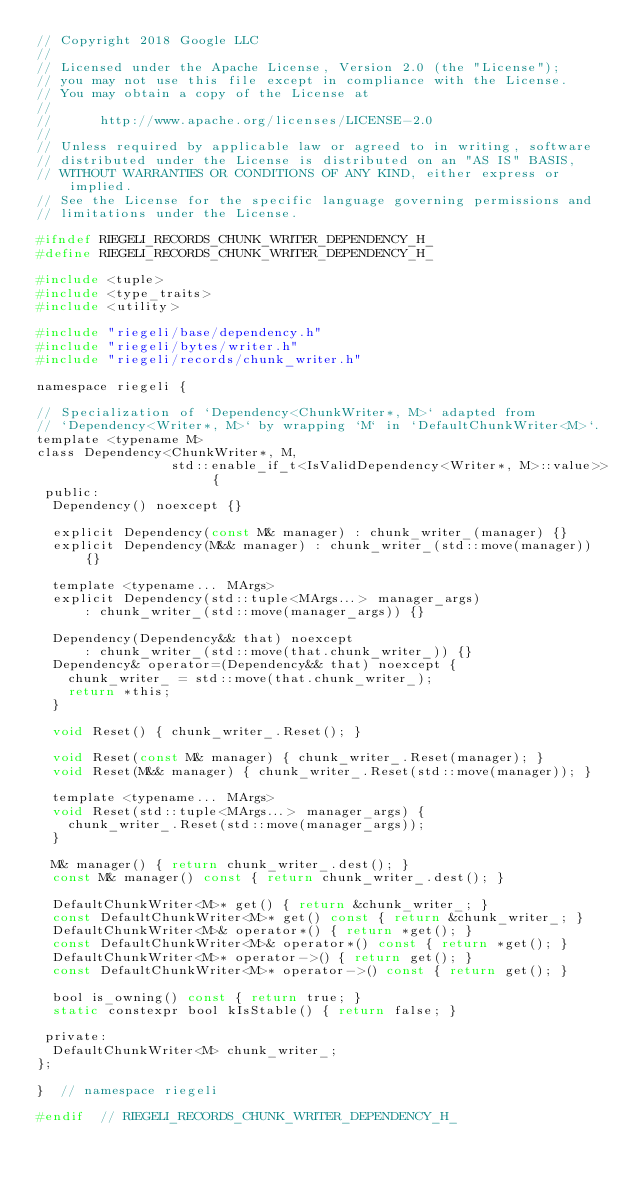<code> <loc_0><loc_0><loc_500><loc_500><_C_>// Copyright 2018 Google LLC
//
// Licensed under the Apache License, Version 2.0 (the "License");
// you may not use this file except in compliance with the License.
// You may obtain a copy of the License at
//
//      http://www.apache.org/licenses/LICENSE-2.0
//
// Unless required by applicable law or agreed to in writing, software
// distributed under the License is distributed on an "AS IS" BASIS,
// WITHOUT WARRANTIES OR CONDITIONS OF ANY KIND, either express or implied.
// See the License for the specific language governing permissions and
// limitations under the License.

#ifndef RIEGELI_RECORDS_CHUNK_WRITER_DEPENDENCY_H_
#define RIEGELI_RECORDS_CHUNK_WRITER_DEPENDENCY_H_

#include <tuple>
#include <type_traits>
#include <utility>

#include "riegeli/base/dependency.h"
#include "riegeli/bytes/writer.h"
#include "riegeli/records/chunk_writer.h"

namespace riegeli {

// Specialization of `Dependency<ChunkWriter*, M>` adapted from
// `Dependency<Writer*, M>` by wrapping `M` in `DefaultChunkWriter<M>`.
template <typename M>
class Dependency<ChunkWriter*, M,
                 std::enable_if_t<IsValidDependency<Writer*, M>::value>> {
 public:
  Dependency() noexcept {}

  explicit Dependency(const M& manager) : chunk_writer_(manager) {}
  explicit Dependency(M&& manager) : chunk_writer_(std::move(manager)) {}

  template <typename... MArgs>
  explicit Dependency(std::tuple<MArgs...> manager_args)
      : chunk_writer_(std::move(manager_args)) {}

  Dependency(Dependency&& that) noexcept
      : chunk_writer_(std::move(that.chunk_writer_)) {}
  Dependency& operator=(Dependency&& that) noexcept {
    chunk_writer_ = std::move(that.chunk_writer_);
    return *this;
  }

  void Reset() { chunk_writer_.Reset(); }

  void Reset(const M& manager) { chunk_writer_.Reset(manager); }
  void Reset(M&& manager) { chunk_writer_.Reset(std::move(manager)); }

  template <typename... MArgs>
  void Reset(std::tuple<MArgs...> manager_args) {
    chunk_writer_.Reset(std::move(manager_args));
  }

  M& manager() { return chunk_writer_.dest(); }
  const M& manager() const { return chunk_writer_.dest(); }

  DefaultChunkWriter<M>* get() { return &chunk_writer_; }
  const DefaultChunkWriter<M>* get() const { return &chunk_writer_; }
  DefaultChunkWriter<M>& operator*() { return *get(); }
  const DefaultChunkWriter<M>& operator*() const { return *get(); }
  DefaultChunkWriter<M>* operator->() { return get(); }
  const DefaultChunkWriter<M>* operator->() const { return get(); }

  bool is_owning() const { return true; }
  static constexpr bool kIsStable() { return false; }

 private:
  DefaultChunkWriter<M> chunk_writer_;
};

}  // namespace riegeli

#endif  // RIEGELI_RECORDS_CHUNK_WRITER_DEPENDENCY_H_
</code> 